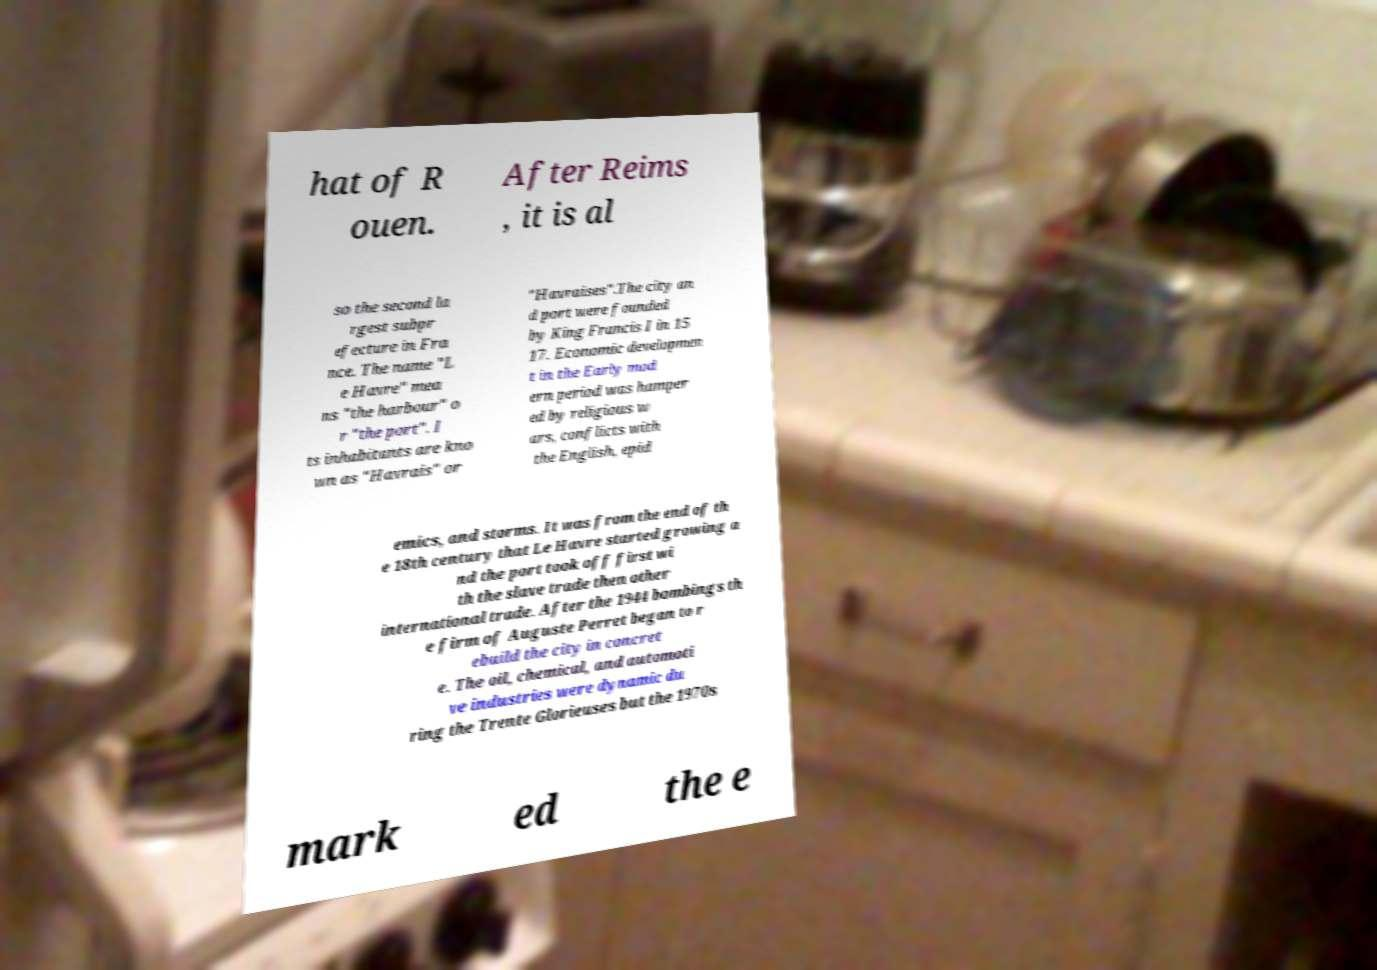There's text embedded in this image that I need extracted. Can you transcribe it verbatim? hat of R ouen. After Reims , it is al so the second la rgest subpr efecture in Fra nce. The name "L e Havre" mea ns "the harbour" o r "the port". I ts inhabitants are kno wn as "Havrais" or "Havraises".The city an d port were founded by King Francis I in 15 17. Economic developmen t in the Early mod ern period was hamper ed by religious w ars, conflicts with the English, epid emics, and storms. It was from the end of th e 18th century that Le Havre started growing a nd the port took off first wi th the slave trade then other international trade. After the 1944 bombings th e firm of Auguste Perret began to r ebuild the city in concret e. The oil, chemical, and automoti ve industries were dynamic du ring the Trente Glorieuses but the 1970s mark ed the e 